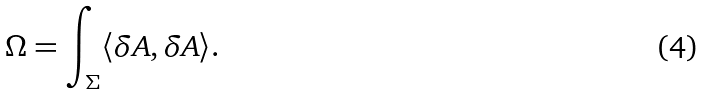<formula> <loc_0><loc_0><loc_500><loc_500>\Omega = \int _ { \Sigma } \langle \delta A , \delta A \rangle .</formula> 